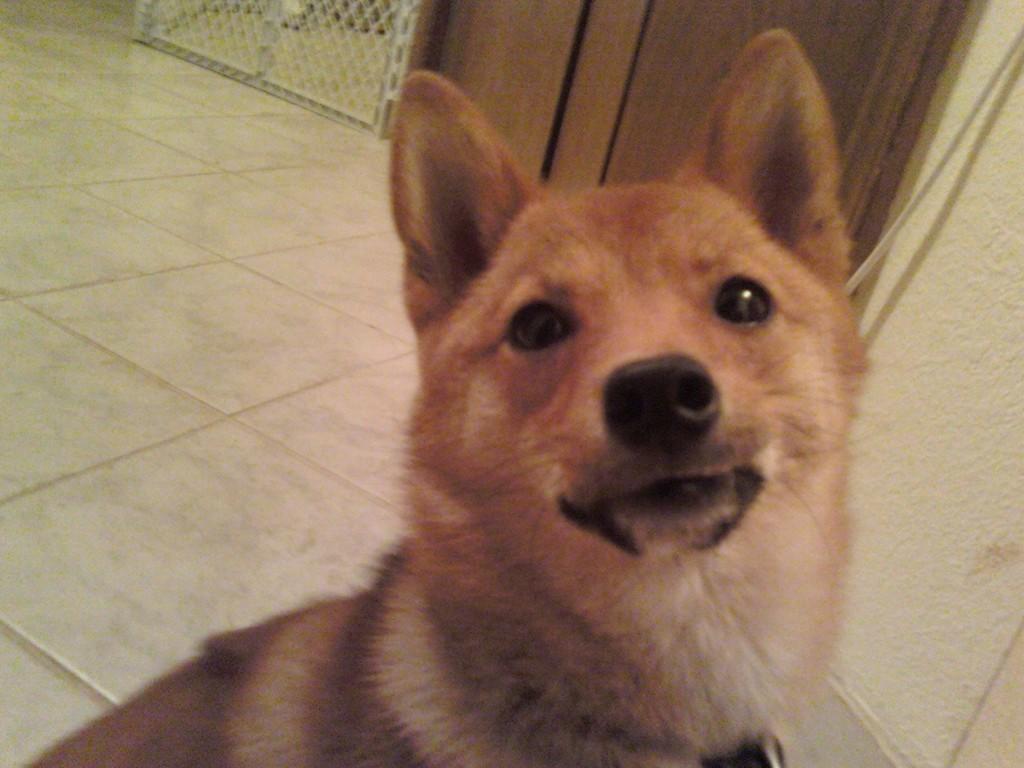In one or two sentences, can you explain what this image depicts? In the picture we can see a tile floor on it, we can see a dog which is brown in color and in the background, we can see a wooden cupboard and beside it we can see a railing. 